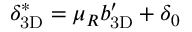Convert formula to latex. <formula><loc_0><loc_0><loc_500><loc_500>{ \delta _ { 3 D } } ^ { * } = \mu _ { R } { b _ { 3 D } ^ { \prime } } + \delta _ { 0 }</formula> 